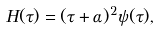Convert formula to latex. <formula><loc_0><loc_0><loc_500><loc_500>H ( \tau ) = ( \tau + \alpha ) ^ { 2 } \psi ( \tau ) ,</formula> 